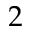<formula> <loc_0><loc_0><loc_500><loc_500>2</formula> 